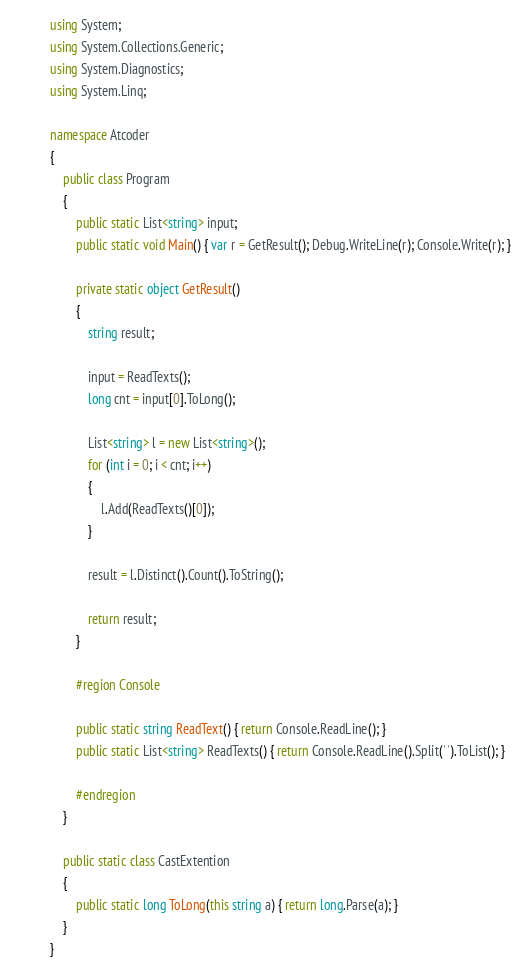Convert code to text. <code><loc_0><loc_0><loc_500><loc_500><_C#_>using System;
using System.Collections.Generic;
using System.Diagnostics;
using System.Linq;

namespace Atcoder
{
    public class Program
    {
        public static List<string> input;
        public static void Main() { var r = GetResult(); Debug.WriteLine(r); Console.Write(r); }

        private static object GetResult()
        {
            string result;
            
            input = ReadTexts();
            long cnt = input[0].ToLong();

            List<string> l = new List<string>();
            for (int i = 0; i < cnt; i++)
            {
                l.Add(ReadTexts()[0]);
            }

            result = l.Distinct().Count().ToString();

            return result;
        }

        #region Console

        public static string ReadText() { return Console.ReadLine(); }
        public static List<string> ReadTexts() { return Console.ReadLine().Split(' ').ToList(); }

        #endregion
    }

    public static class CastExtention
    {
        public static long ToLong(this string a) { return long.Parse(a); }
    }
}

</code> 